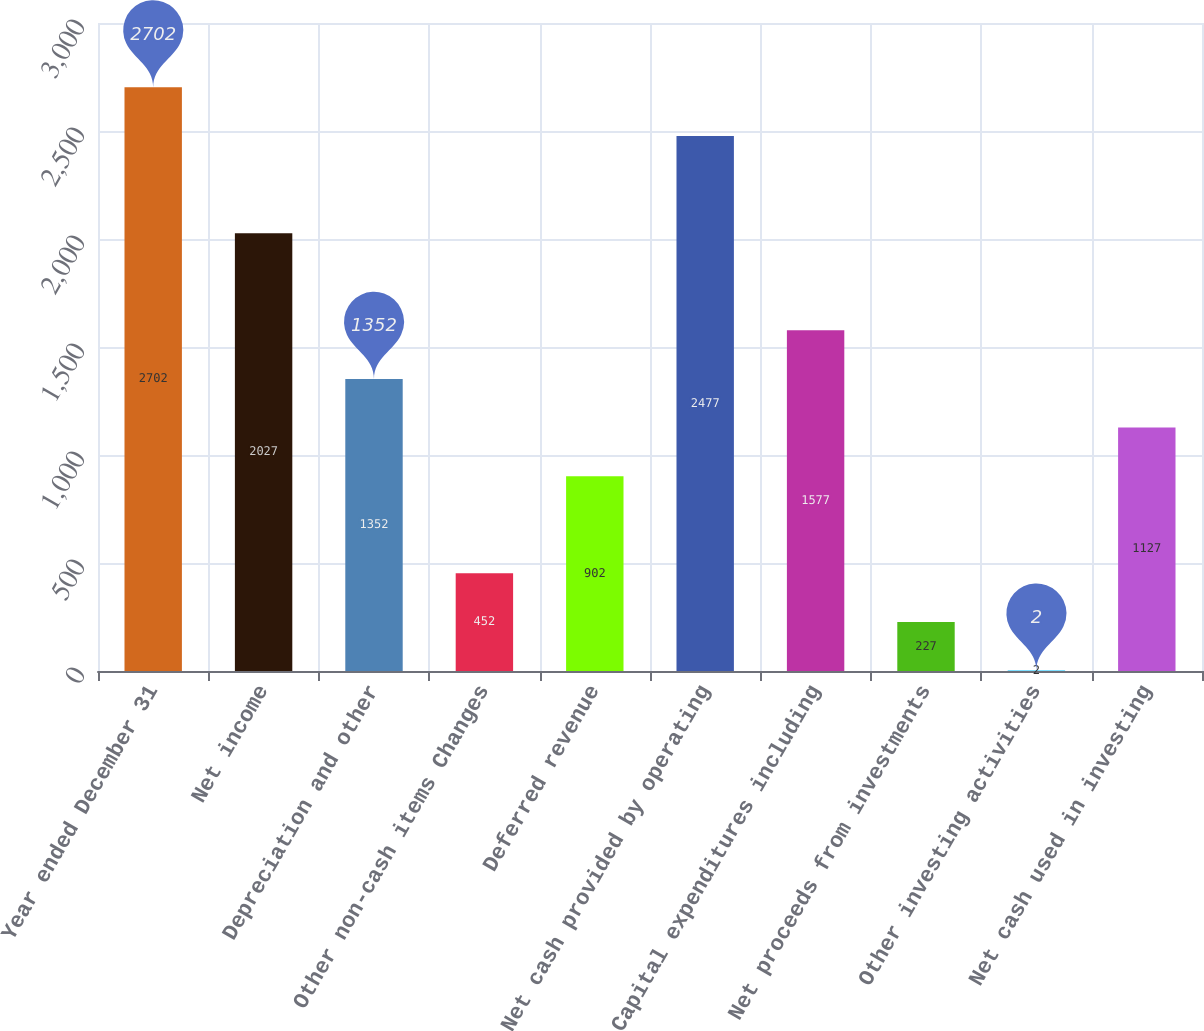Convert chart. <chart><loc_0><loc_0><loc_500><loc_500><bar_chart><fcel>Year ended December 31<fcel>Net income<fcel>Depreciation and other<fcel>Other non-cash items Changes<fcel>Deferred revenue<fcel>Net cash provided by operating<fcel>Capital expenditures including<fcel>Net proceeds from investments<fcel>Other investing activities<fcel>Net cash used in investing<nl><fcel>2702<fcel>2027<fcel>1352<fcel>452<fcel>902<fcel>2477<fcel>1577<fcel>227<fcel>2<fcel>1127<nl></chart> 